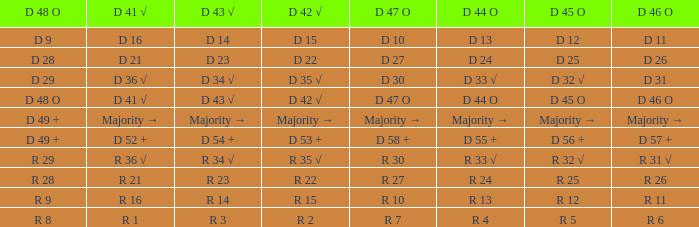Name the D 48 O with D 41 √ of d 41 √ D 48 O. 